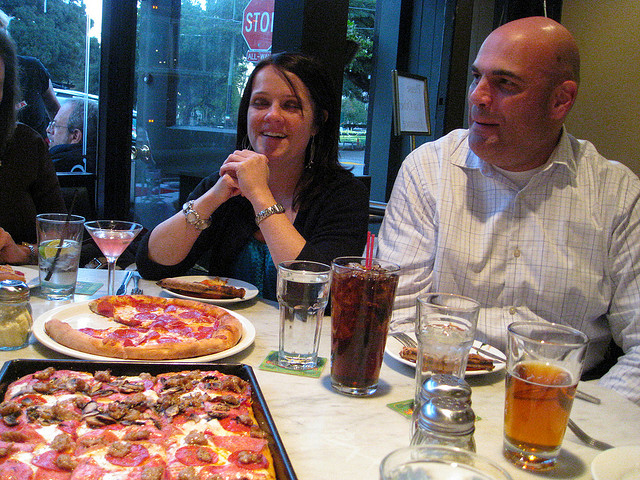How many pizzas are there? There are two pizzas visible in the image, one with pepperoni and the other appears to be a cheese pizza. They're both on the table surrounded by what looks to be a lively dining experience with beverages and people enjoying the meal. 